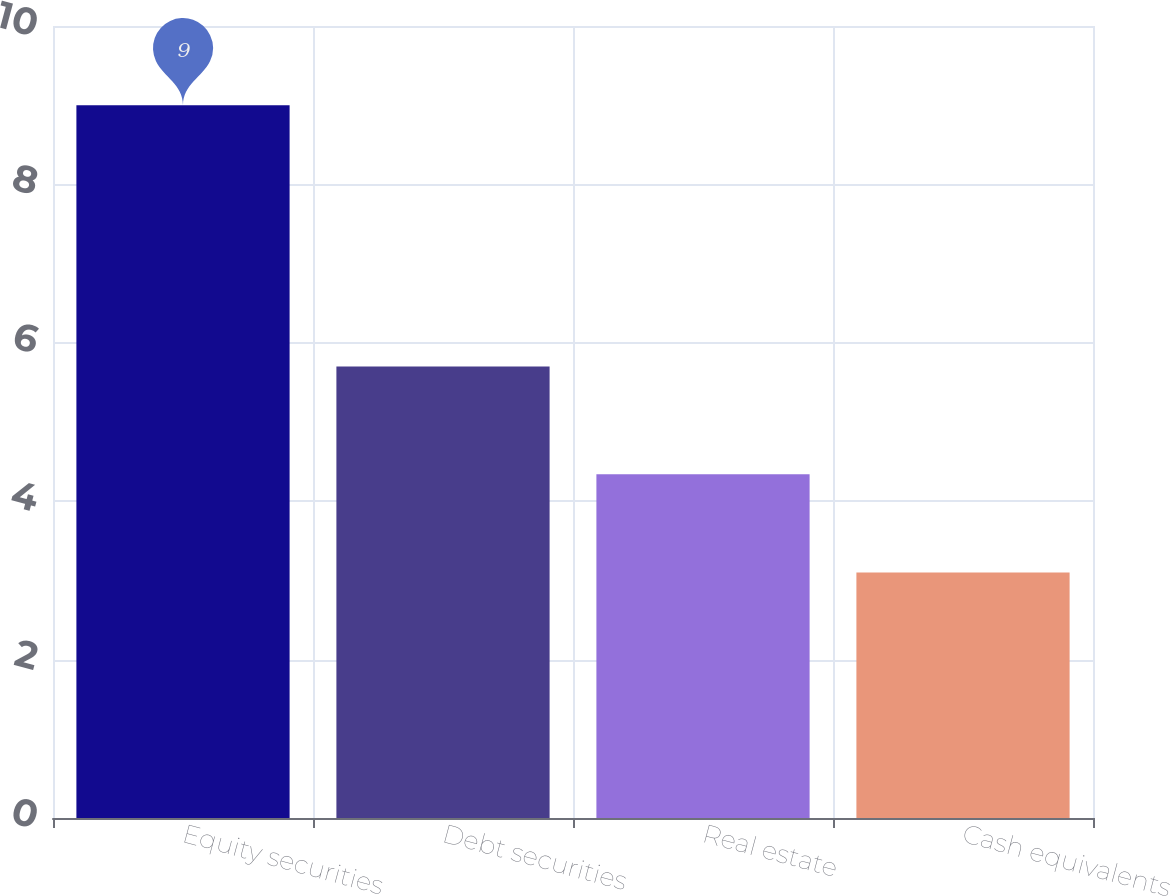Convert chart to OTSL. <chart><loc_0><loc_0><loc_500><loc_500><bar_chart><fcel>Equity securities<fcel>Debt securities<fcel>Real estate<fcel>Cash equivalents<nl><fcel>9<fcel>5.7<fcel>4.34<fcel>3.1<nl></chart> 